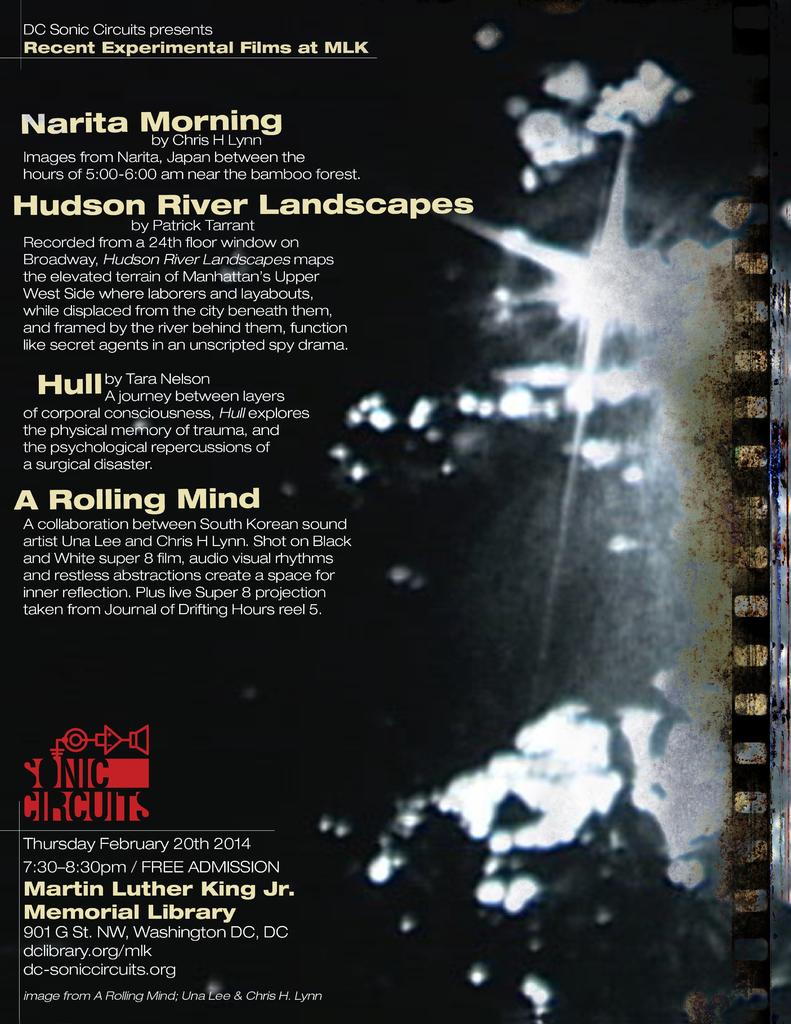What kind of river landscapes?
Provide a short and direct response. Hudson river. What is hull about?
Your response must be concise. A journey between layers. 